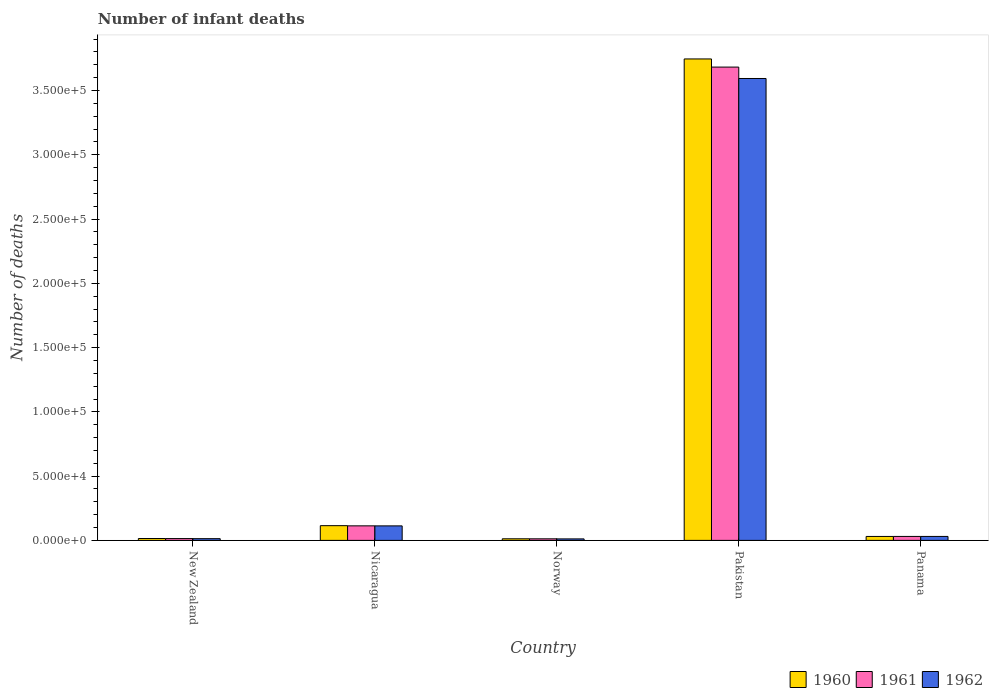How many different coloured bars are there?
Your response must be concise. 3. Are the number of bars per tick equal to the number of legend labels?
Provide a succinct answer. Yes. Are the number of bars on each tick of the X-axis equal?
Provide a short and direct response. Yes. How many bars are there on the 1st tick from the left?
Keep it short and to the point. 3. What is the label of the 1st group of bars from the left?
Your response must be concise. New Zealand. In how many cases, is the number of bars for a given country not equal to the number of legend labels?
Your response must be concise. 0. What is the number of infant deaths in 1961 in Pakistan?
Ensure brevity in your answer.  3.68e+05. Across all countries, what is the maximum number of infant deaths in 1961?
Your answer should be very brief. 3.68e+05. Across all countries, what is the minimum number of infant deaths in 1962?
Offer a terse response. 1165. In which country was the number of infant deaths in 1960 minimum?
Give a very brief answer. Norway. What is the total number of infant deaths in 1962 in the graph?
Your answer should be compact. 3.76e+05. What is the difference between the number of infant deaths in 1960 in Nicaragua and that in Panama?
Provide a succinct answer. 8380. What is the difference between the number of infant deaths in 1961 in New Zealand and the number of infant deaths in 1962 in Nicaragua?
Offer a terse response. -9876. What is the average number of infant deaths in 1961 per country?
Make the answer very short. 7.71e+04. What is the ratio of the number of infant deaths in 1961 in Norway to that in Pakistan?
Your response must be concise. 0. Is the number of infant deaths in 1961 in Nicaragua less than that in Panama?
Your response must be concise. No. What is the difference between the highest and the second highest number of infant deaths in 1961?
Give a very brief answer. -3.65e+05. What is the difference between the highest and the lowest number of infant deaths in 1961?
Make the answer very short. 3.67e+05. In how many countries, is the number of infant deaths in 1961 greater than the average number of infant deaths in 1961 taken over all countries?
Your answer should be compact. 1. Is the sum of the number of infant deaths in 1962 in New Zealand and Norway greater than the maximum number of infant deaths in 1960 across all countries?
Offer a very short reply. No. Is it the case that in every country, the sum of the number of infant deaths in 1960 and number of infant deaths in 1961 is greater than the number of infant deaths in 1962?
Provide a short and direct response. Yes. How many bars are there?
Provide a short and direct response. 15. How many countries are there in the graph?
Provide a succinct answer. 5. What is the difference between two consecutive major ticks on the Y-axis?
Your answer should be compact. 5.00e+04. Does the graph contain grids?
Offer a terse response. No. How many legend labels are there?
Provide a short and direct response. 3. How are the legend labels stacked?
Give a very brief answer. Horizontal. What is the title of the graph?
Keep it short and to the point. Number of infant deaths. What is the label or title of the Y-axis?
Provide a short and direct response. Number of deaths. What is the Number of deaths in 1960 in New Zealand?
Your answer should be compact. 1461. What is the Number of deaths in 1961 in New Zealand?
Ensure brevity in your answer.  1412. What is the Number of deaths of 1962 in New Zealand?
Keep it short and to the point. 1346. What is the Number of deaths in 1960 in Nicaragua?
Keep it short and to the point. 1.15e+04. What is the Number of deaths of 1961 in Nicaragua?
Your response must be concise. 1.13e+04. What is the Number of deaths of 1962 in Nicaragua?
Give a very brief answer. 1.13e+04. What is the Number of deaths of 1960 in Norway?
Keep it short and to the point. 1243. What is the Number of deaths in 1961 in Norway?
Offer a very short reply. 1220. What is the Number of deaths in 1962 in Norway?
Give a very brief answer. 1165. What is the Number of deaths of 1960 in Pakistan?
Offer a terse response. 3.75e+05. What is the Number of deaths in 1961 in Pakistan?
Give a very brief answer. 3.68e+05. What is the Number of deaths of 1962 in Pakistan?
Your answer should be very brief. 3.59e+05. What is the Number of deaths of 1960 in Panama?
Provide a succinct answer. 3074. What is the Number of deaths of 1961 in Panama?
Keep it short and to the point. 3080. What is the Number of deaths in 1962 in Panama?
Make the answer very short. 3077. Across all countries, what is the maximum Number of deaths of 1960?
Your answer should be very brief. 3.75e+05. Across all countries, what is the maximum Number of deaths of 1961?
Your answer should be very brief. 3.68e+05. Across all countries, what is the maximum Number of deaths in 1962?
Your answer should be compact. 3.59e+05. Across all countries, what is the minimum Number of deaths in 1960?
Offer a terse response. 1243. Across all countries, what is the minimum Number of deaths in 1961?
Make the answer very short. 1220. Across all countries, what is the minimum Number of deaths of 1962?
Provide a succinct answer. 1165. What is the total Number of deaths in 1960 in the graph?
Ensure brevity in your answer.  3.92e+05. What is the total Number of deaths in 1961 in the graph?
Provide a succinct answer. 3.85e+05. What is the total Number of deaths in 1962 in the graph?
Your response must be concise. 3.76e+05. What is the difference between the Number of deaths of 1960 in New Zealand and that in Nicaragua?
Provide a succinct answer. -9993. What is the difference between the Number of deaths of 1961 in New Zealand and that in Nicaragua?
Your answer should be very brief. -9898. What is the difference between the Number of deaths of 1962 in New Zealand and that in Nicaragua?
Your answer should be compact. -9942. What is the difference between the Number of deaths in 1960 in New Zealand and that in Norway?
Make the answer very short. 218. What is the difference between the Number of deaths of 1961 in New Zealand and that in Norway?
Provide a succinct answer. 192. What is the difference between the Number of deaths in 1962 in New Zealand and that in Norway?
Make the answer very short. 181. What is the difference between the Number of deaths of 1960 in New Zealand and that in Pakistan?
Offer a very short reply. -3.73e+05. What is the difference between the Number of deaths in 1961 in New Zealand and that in Pakistan?
Ensure brevity in your answer.  -3.67e+05. What is the difference between the Number of deaths of 1962 in New Zealand and that in Pakistan?
Your response must be concise. -3.58e+05. What is the difference between the Number of deaths of 1960 in New Zealand and that in Panama?
Your answer should be compact. -1613. What is the difference between the Number of deaths in 1961 in New Zealand and that in Panama?
Your answer should be very brief. -1668. What is the difference between the Number of deaths in 1962 in New Zealand and that in Panama?
Provide a short and direct response. -1731. What is the difference between the Number of deaths of 1960 in Nicaragua and that in Norway?
Provide a succinct answer. 1.02e+04. What is the difference between the Number of deaths in 1961 in Nicaragua and that in Norway?
Give a very brief answer. 1.01e+04. What is the difference between the Number of deaths of 1962 in Nicaragua and that in Norway?
Your response must be concise. 1.01e+04. What is the difference between the Number of deaths in 1960 in Nicaragua and that in Pakistan?
Provide a short and direct response. -3.63e+05. What is the difference between the Number of deaths of 1961 in Nicaragua and that in Pakistan?
Your response must be concise. -3.57e+05. What is the difference between the Number of deaths in 1962 in Nicaragua and that in Pakistan?
Offer a terse response. -3.48e+05. What is the difference between the Number of deaths of 1960 in Nicaragua and that in Panama?
Provide a succinct answer. 8380. What is the difference between the Number of deaths of 1961 in Nicaragua and that in Panama?
Ensure brevity in your answer.  8230. What is the difference between the Number of deaths in 1962 in Nicaragua and that in Panama?
Your answer should be very brief. 8211. What is the difference between the Number of deaths of 1960 in Norway and that in Pakistan?
Offer a terse response. -3.73e+05. What is the difference between the Number of deaths in 1961 in Norway and that in Pakistan?
Provide a short and direct response. -3.67e+05. What is the difference between the Number of deaths in 1962 in Norway and that in Pakistan?
Offer a very short reply. -3.58e+05. What is the difference between the Number of deaths of 1960 in Norway and that in Panama?
Make the answer very short. -1831. What is the difference between the Number of deaths of 1961 in Norway and that in Panama?
Make the answer very short. -1860. What is the difference between the Number of deaths in 1962 in Norway and that in Panama?
Offer a very short reply. -1912. What is the difference between the Number of deaths of 1960 in Pakistan and that in Panama?
Provide a short and direct response. 3.71e+05. What is the difference between the Number of deaths in 1961 in Pakistan and that in Panama?
Offer a very short reply. 3.65e+05. What is the difference between the Number of deaths in 1962 in Pakistan and that in Panama?
Offer a very short reply. 3.56e+05. What is the difference between the Number of deaths in 1960 in New Zealand and the Number of deaths in 1961 in Nicaragua?
Provide a short and direct response. -9849. What is the difference between the Number of deaths in 1960 in New Zealand and the Number of deaths in 1962 in Nicaragua?
Provide a short and direct response. -9827. What is the difference between the Number of deaths of 1961 in New Zealand and the Number of deaths of 1962 in Nicaragua?
Keep it short and to the point. -9876. What is the difference between the Number of deaths of 1960 in New Zealand and the Number of deaths of 1961 in Norway?
Provide a short and direct response. 241. What is the difference between the Number of deaths in 1960 in New Zealand and the Number of deaths in 1962 in Norway?
Keep it short and to the point. 296. What is the difference between the Number of deaths of 1961 in New Zealand and the Number of deaths of 1962 in Norway?
Your answer should be very brief. 247. What is the difference between the Number of deaths of 1960 in New Zealand and the Number of deaths of 1961 in Pakistan?
Your response must be concise. -3.67e+05. What is the difference between the Number of deaths in 1960 in New Zealand and the Number of deaths in 1962 in Pakistan?
Provide a short and direct response. -3.58e+05. What is the difference between the Number of deaths in 1961 in New Zealand and the Number of deaths in 1962 in Pakistan?
Offer a very short reply. -3.58e+05. What is the difference between the Number of deaths in 1960 in New Zealand and the Number of deaths in 1961 in Panama?
Keep it short and to the point. -1619. What is the difference between the Number of deaths of 1960 in New Zealand and the Number of deaths of 1962 in Panama?
Provide a succinct answer. -1616. What is the difference between the Number of deaths of 1961 in New Zealand and the Number of deaths of 1962 in Panama?
Keep it short and to the point. -1665. What is the difference between the Number of deaths in 1960 in Nicaragua and the Number of deaths in 1961 in Norway?
Give a very brief answer. 1.02e+04. What is the difference between the Number of deaths of 1960 in Nicaragua and the Number of deaths of 1962 in Norway?
Keep it short and to the point. 1.03e+04. What is the difference between the Number of deaths of 1961 in Nicaragua and the Number of deaths of 1962 in Norway?
Offer a terse response. 1.01e+04. What is the difference between the Number of deaths in 1960 in Nicaragua and the Number of deaths in 1961 in Pakistan?
Provide a short and direct response. -3.57e+05. What is the difference between the Number of deaths in 1960 in Nicaragua and the Number of deaths in 1962 in Pakistan?
Keep it short and to the point. -3.48e+05. What is the difference between the Number of deaths in 1961 in Nicaragua and the Number of deaths in 1962 in Pakistan?
Provide a succinct answer. -3.48e+05. What is the difference between the Number of deaths of 1960 in Nicaragua and the Number of deaths of 1961 in Panama?
Offer a very short reply. 8374. What is the difference between the Number of deaths in 1960 in Nicaragua and the Number of deaths in 1962 in Panama?
Make the answer very short. 8377. What is the difference between the Number of deaths of 1961 in Nicaragua and the Number of deaths of 1962 in Panama?
Offer a very short reply. 8233. What is the difference between the Number of deaths in 1960 in Norway and the Number of deaths in 1961 in Pakistan?
Ensure brevity in your answer.  -3.67e+05. What is the difference between the Number of deaths of 1960 in Norway and the Number of deaths of 1962 in Pakistan?
Your answer should be very brief. -3.58e+05. What is the difference between the Number of deaths of 1961 in Norway and the Number of deaths of 1962 in Pakistan?
Offer a very short reply. -3.58e+05. What is the difference between the Number of deaths in 1960 in Norway and the Number of deaths in 1961 in Panama?
Ensure brevity in your answer.  -1837. What is the difference between the Number of deaths in 1960 in Norway and the Number of deaths in 1962 in Panama?
Ensure brevity in your answer.  -1834. What is the difference between the Number of deaths of 1961 in Norway and the Number of deaths of 1962 in Panama?
Your response must be concise. -1857. What is the difference between the Number of deaths in 1960 in Pakistan and the Number of deaths in 1961 in Panama?
Provide a succinct answer. 3.71e+05. What is the difference between the Number of deaths in 1960 in Pakistan and the Number of deaths in 1962 in Panama?
Give a very brief answer. 3.71e+05. What is the difference between the Number of deaths in 1961 in Pakistan and the Number of deaths in 1962 in Panama?
Keep it short and to the point. 3.65e+05. What is the average Number of deaths in 1960 per country?
Offer a very short reply. 7.84e+04. What is the average Number of deaths in 1961 per country?
Your answer should be compact. 7.71e+04. What is the average Number of deaths in 1962 per country?
Your answer should be compact. 7.52e+04. What is the difference between the Number of deaths of 1960 and Number of deaths of 1962 in New Zealand?
Offer a terse response. 115. What is the difference between the Number of deaths in 1961 and Number of deaths in 1962 in New Zealand?
Your response must be concise. 66. What is the difference between the Number of deaths in 1960 and Number of deaths in 1961 in Nicaragua?
Offer a very short reply. 144. What is the difference between the Number of deaths of 1960 and Number of deaths of 1962 in Nicaragua?
Make the answer very short. 166. What is the difference between the Number of deaths of 1961 and Number of deaths of 1962 in Nicaragua?
Your response must be concise. 22. What is the difference between the Number of deaths of 1961 and Number of deaths of 1962 in Norway?
Ensure brevity in your answer.  55. What is the difference between the Number of deaths in 1960 and Number of deaths in 1961 in Pakistan?
Your response must be concise. 6334. What is the difference between the Number of deaths of 1960 and Number of deaths of 1962 in Pakistan?
Provide a succinct answer. 1.52e+04. What is the difference between the Number of deaths of 1961 and Number of deaths of 1962 in Pakistan?
Offer a very short reply. 8871. What is the difference between the Number of deaths of 1960 and Number of deaths of 1961 in Panama?
Your answer should be very brief. -6. What is the ratio of the Number of deaths in 1960 in New Zealand to that in Nicaragua?
Offer a terse response. 0.13. What is the ratio of the Number of deaths in 1961 in New Zealand to that in Nicaragua?
Make the answer very short. 0.12. What is the ratio of the Number of deaths of 1962 in New Zealand to that in Nicaragua?
Your response must be concise. 0.12. What is the ratio of the Number of deaths of 1960 in New Zealand to that in Norway?
Provide a short and direct response. 1.18. What is the ratio of the Number of deaths of 1961 in New Zealand to that in Norway?
Your answer should be very brief. 1.16. What is the ratio of the Number of deaths in 1962 in New Zealand to that in Norway?
Offer a very short reply. 1.16. What is the ratio of the Number of deaths in 1960 in New Zealand to that in Pakistan?
Your answer should be very brief. 0. What is the ratio of the Number of deaths in 1961 in New Zealand to that in Pakistan?
Offer a very short reply. 0. What is the ratio of the Number of deaths in 1962 in New Zealand to that in Pakistan?
Ensure brevity in your answer.  0. What is the ratio of the Number of deaths of 1960 in New Zealand to that in Panama?
Provide a short and direct response. 0.48. What is the ratio of the Number of deaths of 1961 in New Zealand to that in Panama?
Your answer should be compact. 0.46. What is the ratio of the Number of deaths of 1962 in New Zealand to that in Panama?
Keep it short and to the point. 0.44. What is the ratio of the Number of deaths in 1960 in Nicaragua to that in Norway?
Make the answer very short. 9.21. What is the ratio of the Number of deaths in 1961 in Nicaragua to that in Norway?
Your answer should be very brief. 9.27. What is the ratio of the Number of deaths of 1962 in Nicaragua to that in Norway?
Your answer should be very brief. 9.69. What is the ratio of the Number of deaths in 1960 in Nicaragua to that in Pakistan?
Provide a short and direct response. 0.03. What is the ratio of the Number of deaths in 1961 in Nicaragua to that in Pakistan?
Offer a very short reply. 0.03. What is the ratio of the Number of deaths in 1962 in Nicaragua to that in Pakistan?
Give a very brief answer. 0.03. What is the ratio of the Number of deaths in 1960 in Nicaragua to that in Panama?
Ensure brevity in your answer.  3.73. What is the ratio of the Number of deaths in 1961 in Nicaragua to that in Panama?
Provide a succinct answer. 3.67. What is the ratio of the Number of deaths of 1962 in Nicaragua to that in Panama?
Make the answer very short. 3.67. What is the ratio of the Number of deaths of 1960 in Norway to that in Pakistan?
Give a very brief answer. 0. What is the ratio of the Number of deaths of 1961 in Norway to that in Pakistan?
Provide a short and direct response. 0. What is the ratio of the Number of deaths of 1962 in Norway to that in Pakistan?
Offer a terse response. 0. What is the ratio of the Number of deaths in 1960 in Norway to that in Panama?
Provide a short and direct response. 0.4. What is the ratio of the Number of deaths of 1961 in Norway to that in Panama?
Your response must be concise. 0.4. What is the ratio of the Number of deaths in 1962 in Norway to that in Panama?
Offer a very short reply. 0.38. What is the ratio of the Number of deaths of 1960 in Pakistan to that in Panama?
Keep it short and to the point. 121.85. What is the ratio of the Number of deaths of 1961 in Pakistan to that in Panama?
Your response must be concise. 119.55. What is the ratio of the Number of deaths in 1962 in Pakistan to that in Panama?
Offer a very short reply. 116.79. What is the difference between the highest and the second highest Number of deaths of 1960?
Give a very brief answer. 3.63e+05. What is the difference between the highest and the second highest Number of deaths of 1961?
Your answer should be compact. 3.57e+05. What is the difference between the highest and the second highest Number of deaths in 1962?
Offer a very short reply. 3.48e+05. What is the difference between the highest and the lowest Number of deaths of 1960?
Make the answer very short. 3.73e+05. What is the difference between the highest and the lowest Number of deaths of 1961?
Keep it short and to the point. 3.67e+05. What is the difference between the highest and the lowest Number of deaths of 1962?
Your answer should be very brief. 3.58e+05. 